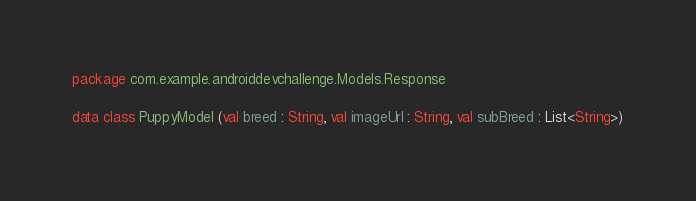Convert code to text. <code><loc_0><loc_0><loc_500><loc_500><_Kotlin_>package com.example.androiddevchallenge.Models.Response

data class PuppyModel (val breed : String, val imageUrl : String, val subBreed : List<String>)</code> 